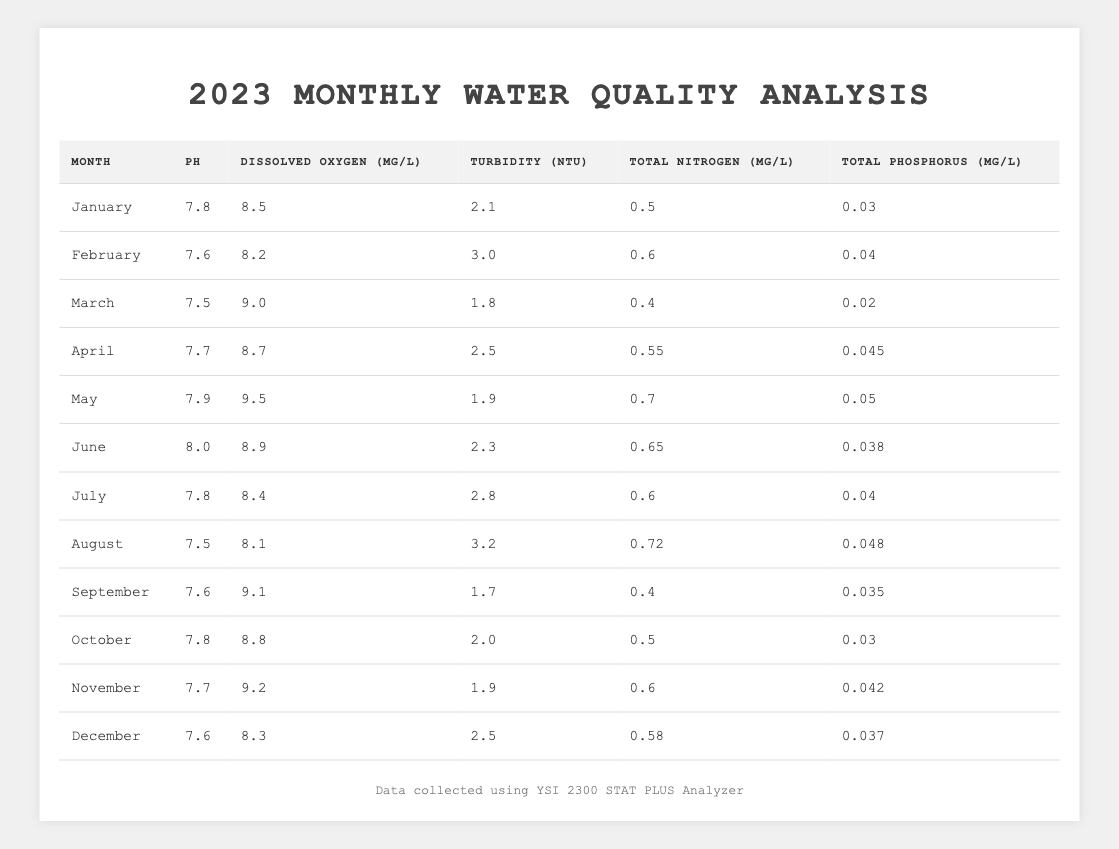What was the pH level in May? The table indicates that the pH level recorded in May is found in the corresponding row under the pH column. According to the table, it is 7.9.
Answer: 7.9 Which month had the highest dissolved oxygen level? By inspecting the dissolved oxygen values in the table, May has the highest value of 9.5 mg/L when compared to other months.
Answer: May What is the average turbidity level for the first half of the year (January to June)? The turbidity values for January to June are 2.1, 3.0, 1.8, 2.5, 1.9, and 2.3. Adding these gives us a total of 13.6, and since there are 6 months, we calculate the average as 13.6 / 6 = 2.27.
Answer: 2.27 Is the total phosphorus level higher in June than in February? By comparing the total phosphorus levels in the table, June has a value of 0.038 mg/L while February has a value of 0.04 mg/L. Since 0.038 is less than 0.04, June's level is not higher than February's.
Answer: No What was the difference in total nitrogen levels between July and March? The total nitrogen level for July is 0.6 mg/L and for March it is 0.4 mg/L. To find the difference, subtract March's value from July's: 0.6 - 0.4 = 0.2 mg/L.
Answer: 0.2 mg/L Which month had the lowest turbidity level? Looking at the turbidity values, March has the lowest level at 1.8 NTU, making it the month with the least turbidity.
Answer: March What is the median pH level of the water quality samples for 2023? Arranging the pH values from the table: 7.5, 7.5, 7.6, 7.6, 7.7, 7.7, 7.8, 7.8, 7.9, 8.0. Since there are 12 values, the median will be the average of the 6th and 7th values (7.7 and 7.8). Therefore, (7.7 + 7.8) / 2 = 7.75.
Answer: 7.75 Was the dissolved oxygen level consistently above 8 mg/L in the first six months of the year? Checking the dissolved oxygen levels for January (8.5), February (8.2), March (9.0), April (8.7), May (9.5), and June (8.9), all values are above 8 mg/L, confirming consistency.
Answer: Yes What is the total amount of total phosphorus recorded from January to March? The total phosphorus for January is 0.03, February is 0.04, and March is 0.02. Adding these gives: 0.03 + 0.04 + 0.02 = 0.09 mg/L.
Answer: 0.09 mg/L How many months had a total nitrogen level greater than 0.6 mg/L? Evaluating the total nitrogen levels, the months with levels greater than 0.6 mg/L are May (0.7 mg/L) and August (0.72 mg/L). Thus, there are 2 months with such levels.
Answer: 2 